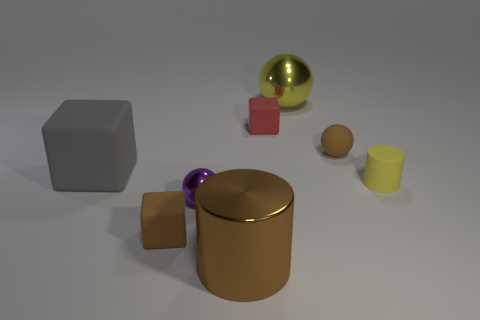Could you describe the spatial arrangement of the objects? The objects are arranged in an intriguing composition that suggests deliberate placement for visual balance. The gray cube and brown cylinder anchor the scene with their larger forms and central positioning. The smaller blocks and spheres seem to be scattered to the right, creating a sense of movement leading the eye from left to right. The variety in size and spacing between the objects gives the composition a dynamic feel, as if each item occupies its own distinct space within the greater whole. 